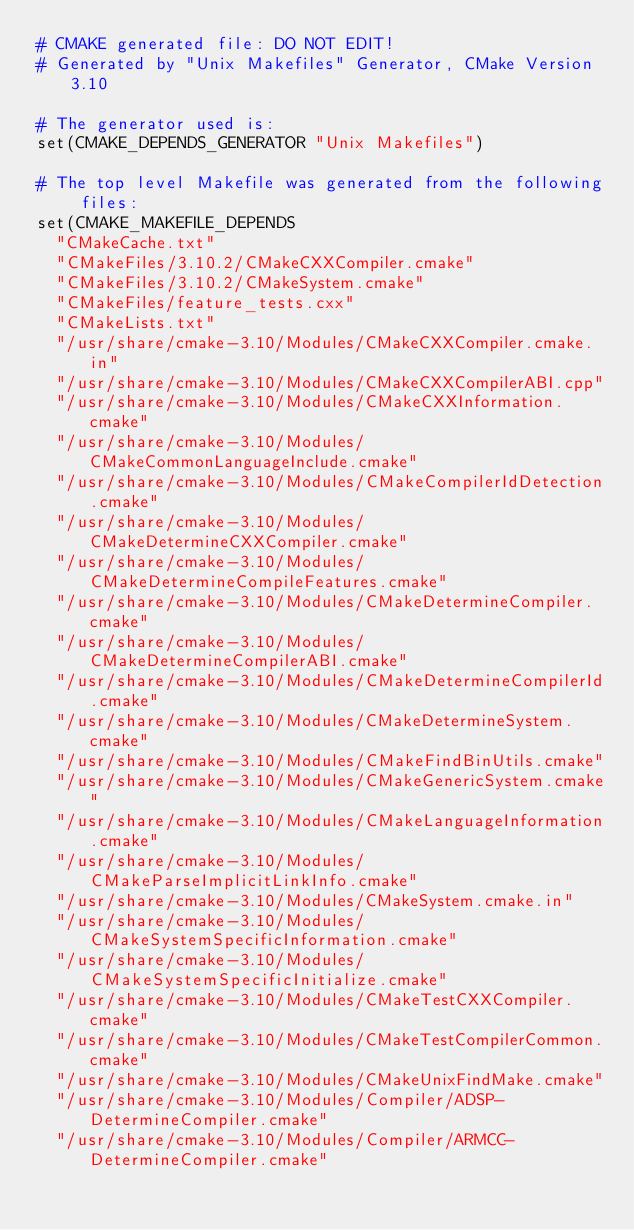<code> <loc_0><loc_0><loc_500><loc_500><_CMake_># CMAKE generated file: DO NOT EDIT!
# Generated by "Unix Makefiles" Generator, CMake Version 3.10

# The generator used is:
set(CMAKE_DEPENDS_GENERATOR "Unix Makefiles")

# The top level Makefile was generated from the following files:
set(CMAKE_MAKEFILE_DEPENDS
  "CMakeCache.txt"
  "CMakeFiles/3.10.2/CMakeCXXCompiler.cmake"
  "CMakeFiles/3.10.2/CMakeSystem.cmake"
  "CMakeFiles/feature_tests.cxx"
  "CMakeLists.txt"
  "/usr/share/cmake-3.10/Modules/CMakeCXXCompiler.cmake.in"
  "/usr/share/cmake-3.10/Modules/CMakeCXXCompilerABI.cpp"
  "/usr/share/cmake-3.10/Modules/CMakeCXXInformation.cmake"
  "/usr/share/cmake-3.10/Modules/CMakeCommonLanguageInclude.cmake"
  "/usr/share/cmake-3.10/Modules/CMakeCompilerIdDetection.cmake"
  "/usr/share/cmake-3.10/Modules/CMakeDetermineCXXCompiler.cmake"
  "/usr/share/cmake-3.10/Modules/CMakeDetermineCompileFeatures.cmake"
  "/usr/share/cmake-3.10/Modules/CMakeDetermineCompiler.cmake"
  "/usr/share/cmake-3.10/Modules/CMakeDetermineCompilerABI.cmake"
  "/usr/share/cmake-3.10/Modules/CMakeDetermineCompilerId.cmake"
  "/usr/share/cmake-3.10/Modules/CMakeDetermineSystem.cmake"
  "/usr/share/cmake-3.10/Modules/CMakeFindBinUtils.cmake"
  "/usr/share/cmake-3.10/Modules/CMakeGenericSystem.cmake"
  "/usr/share/cmake-3.10/Modules/CMakeLanguageInformation.cmake"
  "/usr/share/cmake-3.10/Modules/CMakeParseImplicitLinkInfo.cmake"
  "/usr/share/cmake-3.10/Modules/CMakeSystem.cmake.in"
  "/usr/share/cmake-3.10/Modules/CMakeSystemSpecificInformation.cmake"
  "/usr/share/cmake-3.10/Modules/CMakeSystemSpecificInitialize.cmake"
  "/usr/share/cmake-3.10/Modules/CMakeTestCXXCompiler.cmake"
  "/usr/share/cmake-3.10/Modules/CMakeTestCompilerCommon.cmake"
  "/usr/share/cmake-3.10/Modules/CMakeUnixFindMake.cmake"
  "/usr/share/cmake-3.10/Modules/Compiler/ADSP-DetermineCompiler.cmake"
  "/usr/share/cmake-3.10/Modules/Compiler/ARMCC-DetermineCompiler.cmake"</code> 